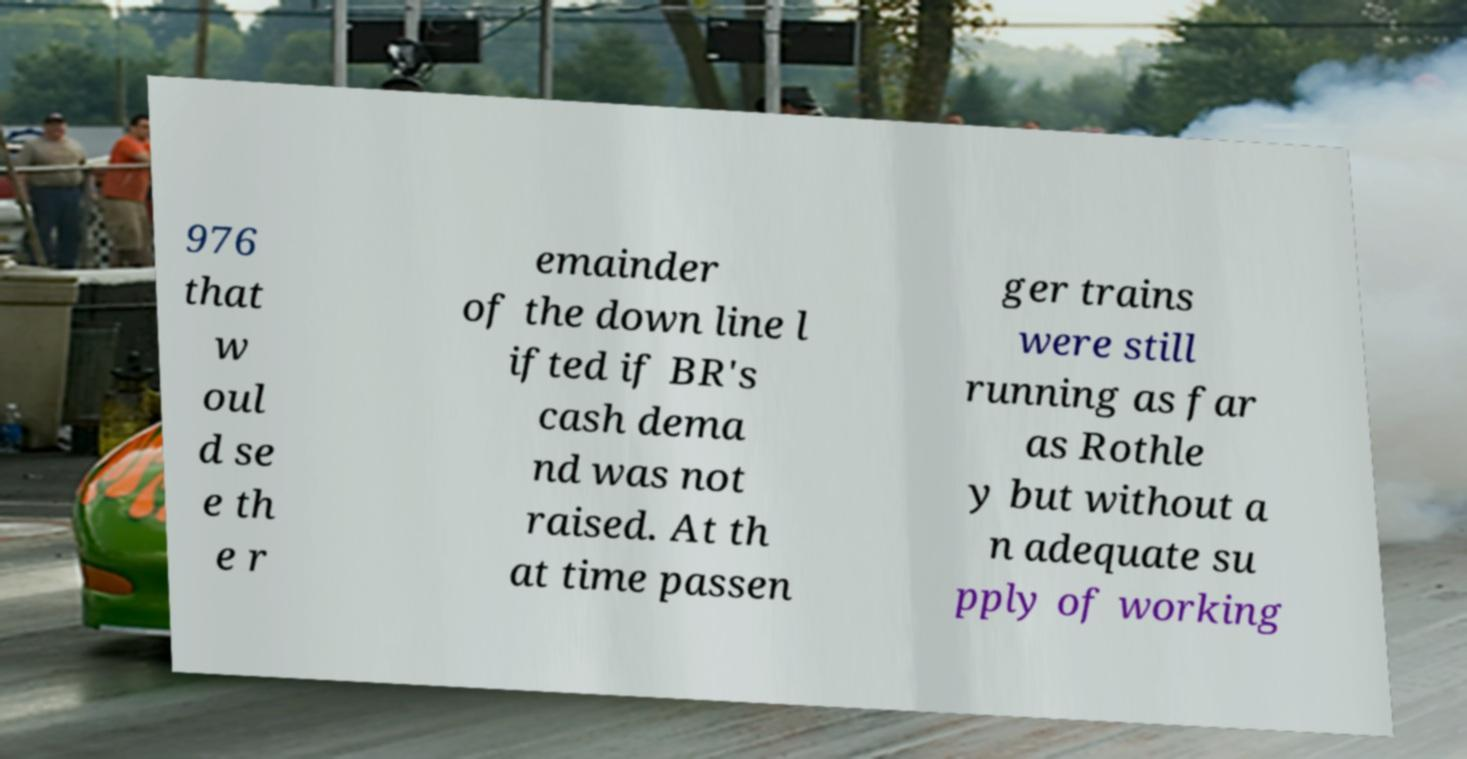Could you assist in decoding the text presented in this image and type it out clearly? 976 that w oul d se e th e r emainder of the down line l ifted if BR's cash dema nd was not raised. At th at time passen ger trains were still running as far as Rothle y but without a n adequate su pply of working 